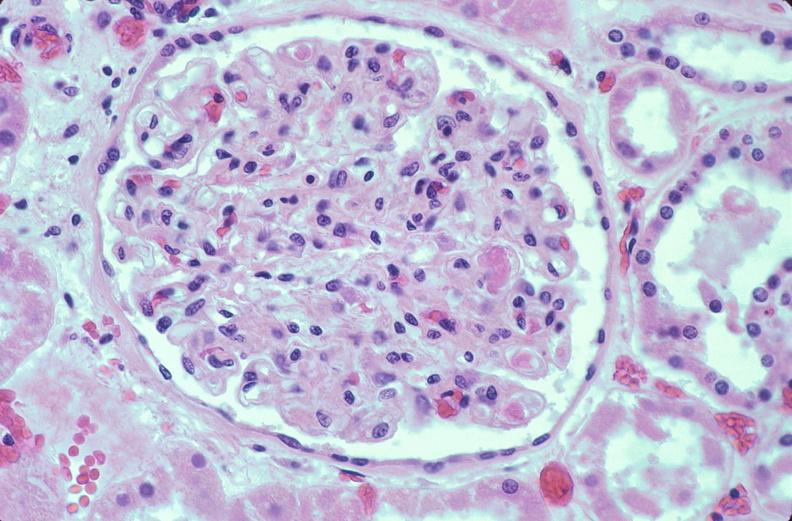where is this?
Answer the question using a single word or phrase. Urinary 